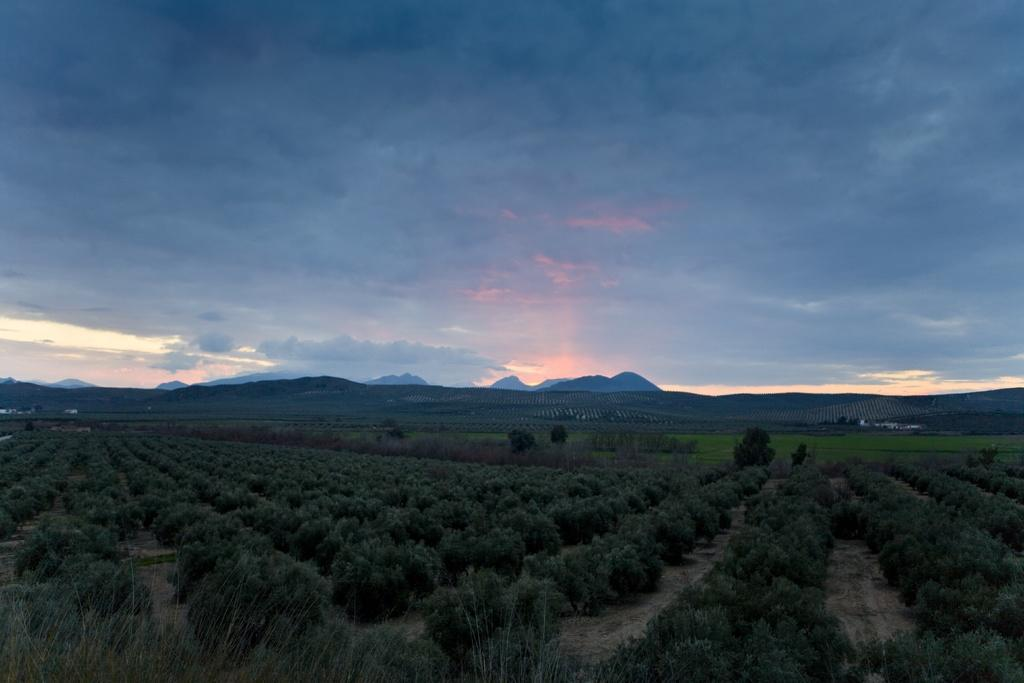What type of vegetation can be seen in the image? There are trees and grass in the image. What can be seen in the background of the image? There are hills visible in the background of the image. What is visible at the top of the image? The sky is visible at the top of the image. What can be observed in the sky? Clouds are present in the sky. How many places are visible in the image? The term "place" is not relevant to the image, as it does not depict specific locations or destinations. The image primarily features natural elements such as trees, grass, hills, and the sky. What type of trouble can be seen in the image? There is no indication of trouble or any negative situation in the image. The image primarily features natural elements such as trees, grass, hills, and the sky. 